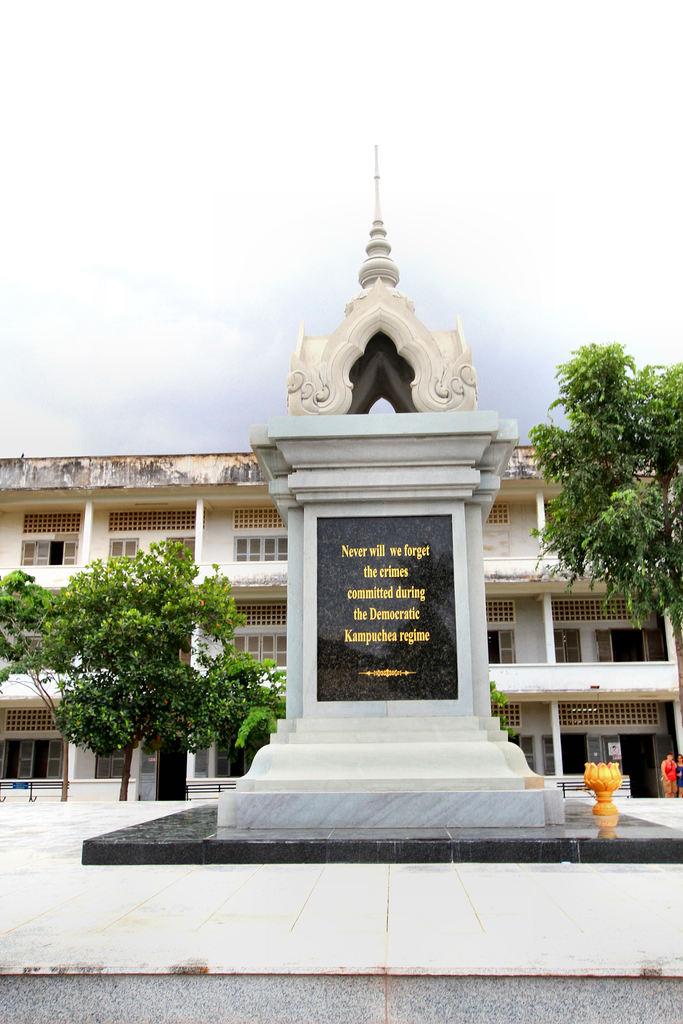What does the statue say?
Your answer should be compact. Never will we forget the crimes committed during the democratic kampuchea regime. What color are the letters on the monument?
Give a very brief answer. Gold. 